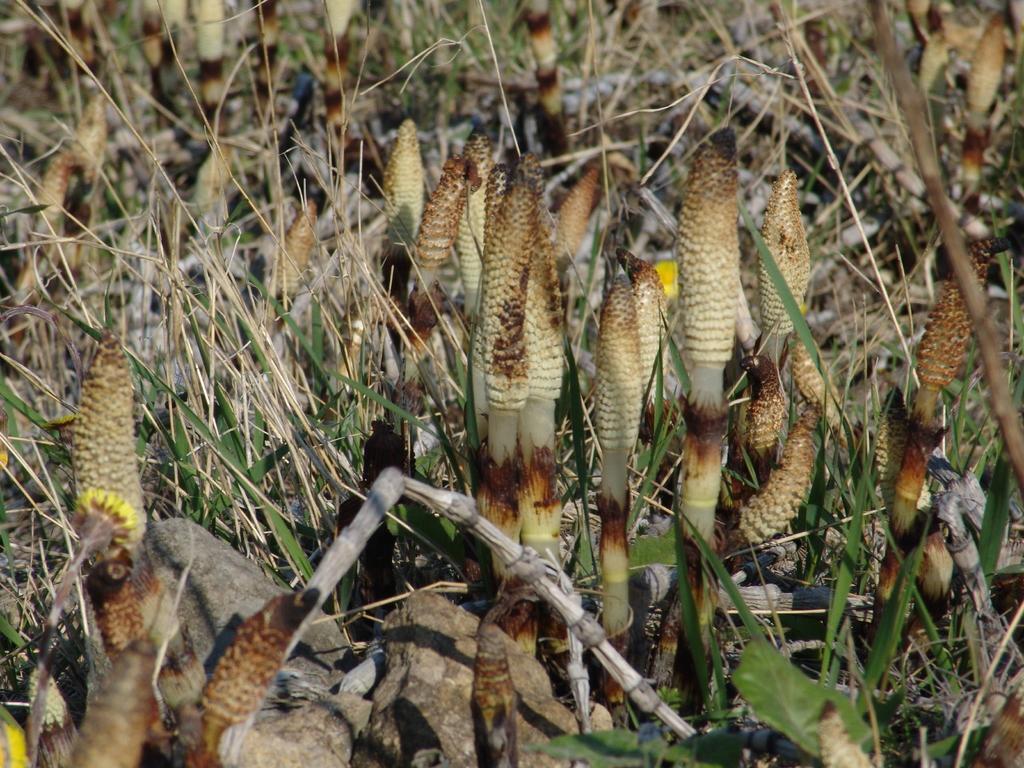Can you describe this image briefly? In this image we can see group of plants. 